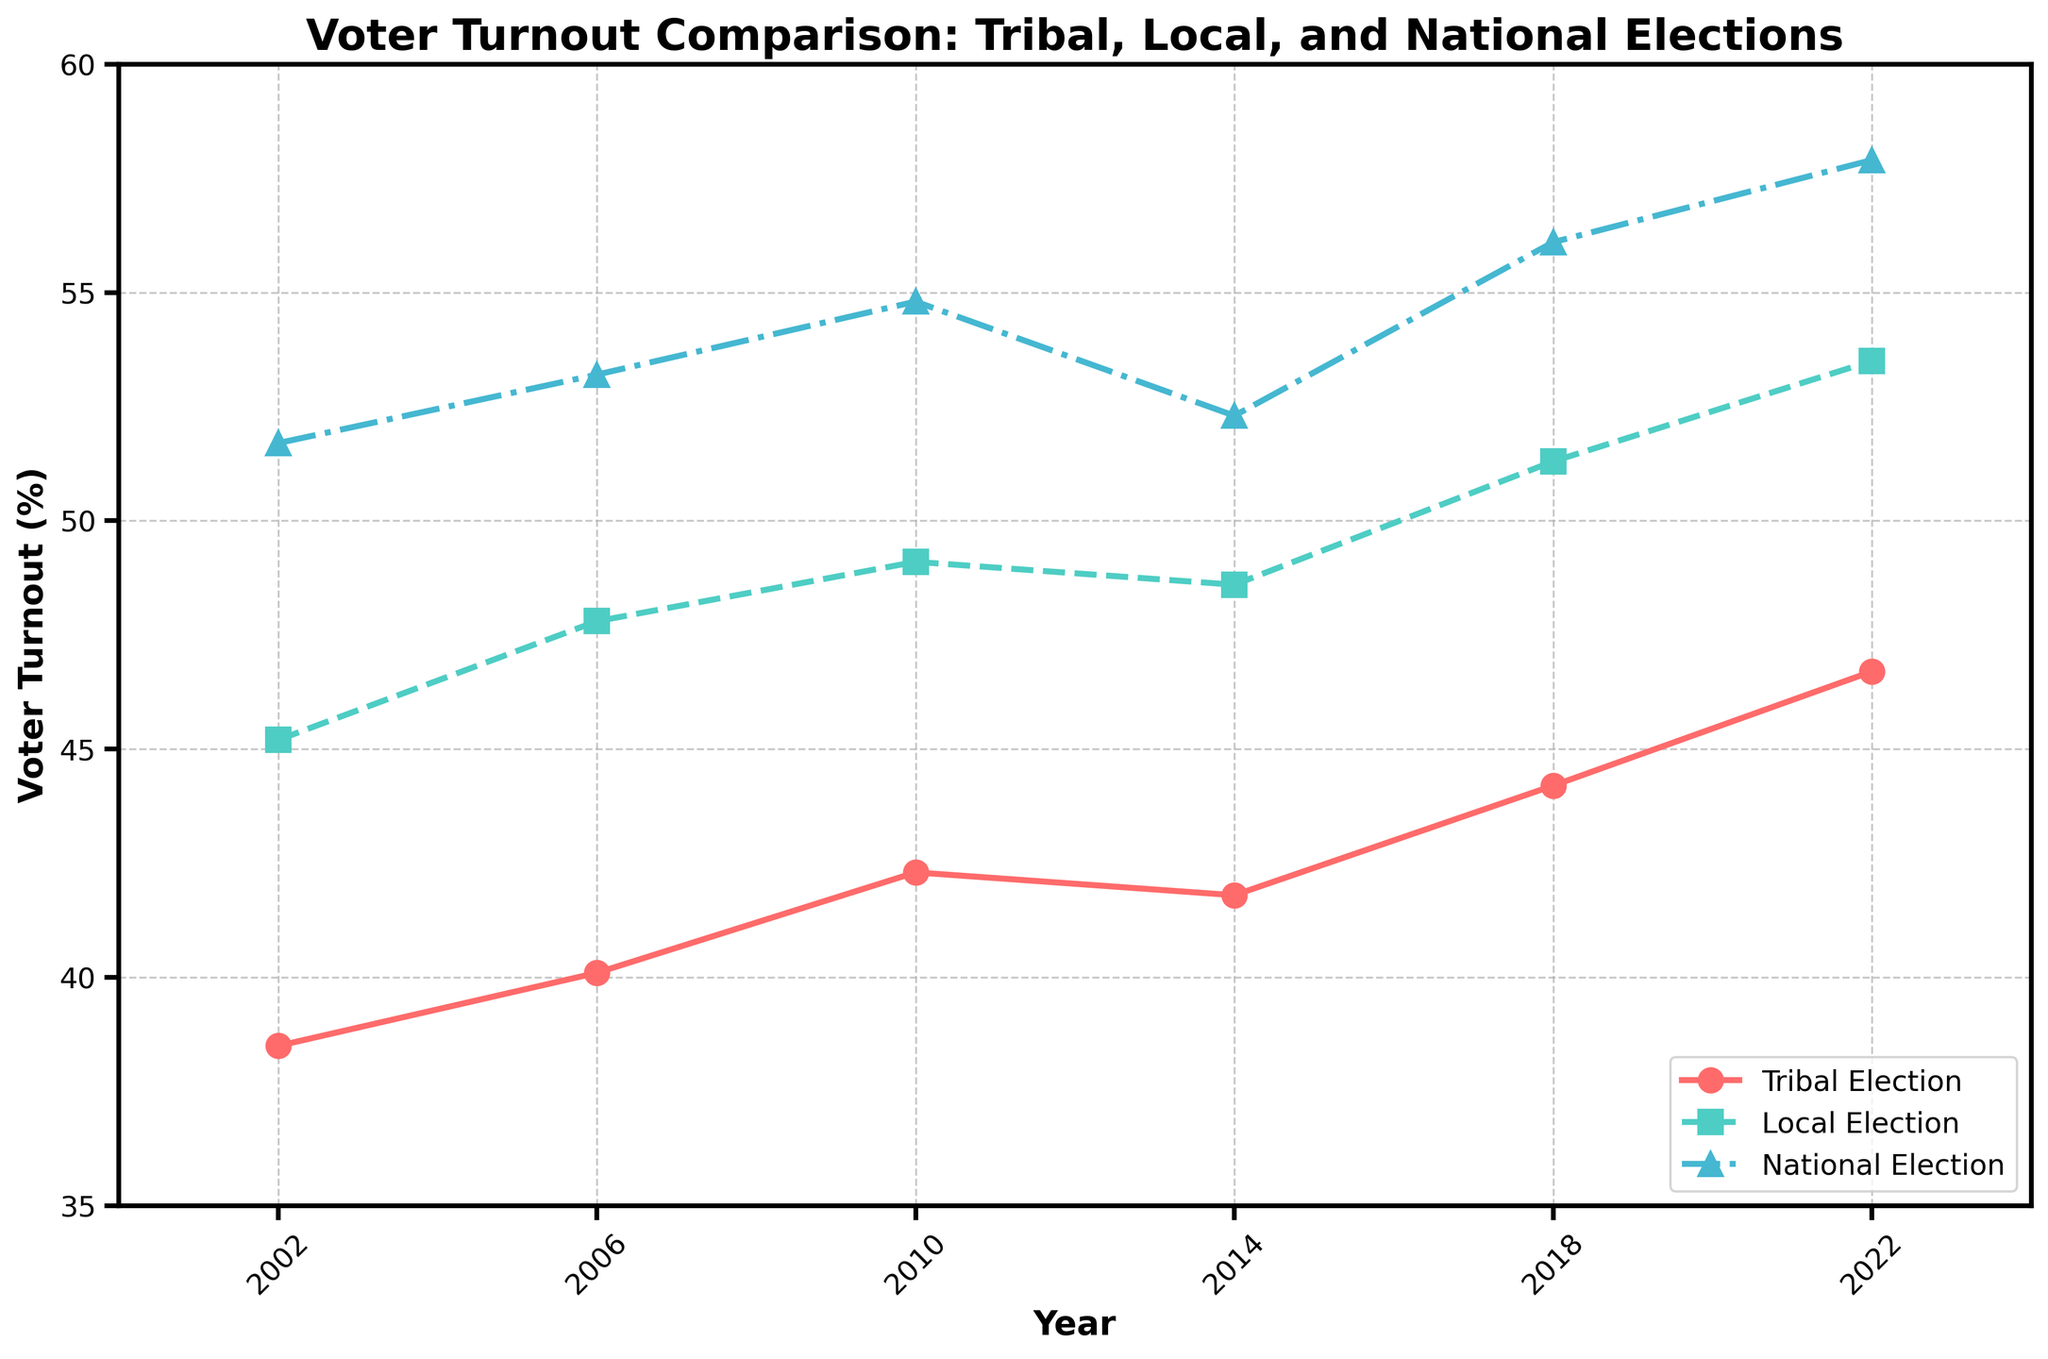What is the title of the figure? The title can be found at the top of the figure and it gives an overall idea of what the figure illustrates.
Answer: Voter Turnout Comparison: Tribal, Local, and National Elections How many years are represented in the figure? Count the data points along the x-axis to determine the number of years being represented.
Answer: 6 Which election had the highest voter turnout in 2022 and what was the turnout percentage? Check the y-axis values for the year 2022 and compare the voter turnout percentages for the tribal, local, and national elections.
Answer: National Election, 57.9% What was the trend for the voter turnout in tribal elections from 2002 to 2022? Look at the line representing the tribal elections and observe the general direction of the line from 2002 to 2022 to determine the trend.
Answer: Increasing How much did the voter turnout for local elections change from 2014 to 2018? Find the voter turnout values for local elections in 2014 and 2018 and then calculate the difference between these two values.
Answer: Increased by 2.7% In which year did the voter turnout for tribal elections surpass 40%? Look at the voter turnout values for tribal elections and identify the first year when the value exceeds 40%.
Answer: 2006 Between which years was the smallest change in voter turnout for national elections? Compare the voter turnout values year by year for national elections and identify the pair of consecutive years with the smallest difference.
Answer: 2014 to 2018 What is the average voter turnout for tribal elections over the 20-year period? Sum up the voter turnout percentages for tribal elections from 2002 to 2022 and then divide by the number of years to find the average.
Answer: (38.5 + 40.1 + 42.3 + 41.8 + 44.2 + 46.7) / 6 = 42.6 Which election had the smallest voter turnout difference between 2002 and 2022? Determine the voter turnout percentage differences for tribal, local, and national elections between 2002 and 2022 and identify the smallest difference.
Answer: Tribal Election, 8.2% In what year did the voter turnout for local elections first exceed 50%? Look at the voter turnout percentages for local elections and identify the first year in which the percentage goes beyond 50%.
Answer: 2018 